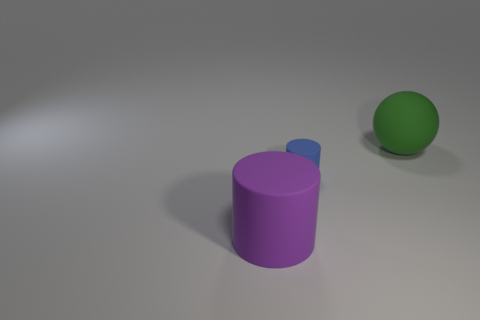What color is the object that is behind the large purple rubber thing and left of the large green object?
Your response must be concise. Blue. What material is the cylinder right of the big purple cylinder?
Offer a very short reply. Rubber. What is the size of the purple matte cylinder?
Your answer should be compact. Large. How many purple objects are cylinders or tiny rubber cylinders?
Ensure brevity in your answer.  1. There is a rubber cylinder behind the matte thing on the left side of the blue matte cylinder; how big is it?
Your response must be concise. Small. There is a large cylinder; is its color the same as the big thing that is on the right side of the blue rubber cylinder?
Offer a very short reply. No. What shape is the purple thing that is the same material as the green sphere?
Your answer should be compact. Cylinder. Is there any other thing of the same color as the tiny matte cylinder?
Provide a succinct answer. No. Is the number of tiny blue things to the left of the big green rubber thing greater than the number of green things?
Ensure brevity in your answer.  No. There is a blue rubber object; is its shape the same as the big object in front of the green rubber ball?
Offer a very short reply. Yes. 